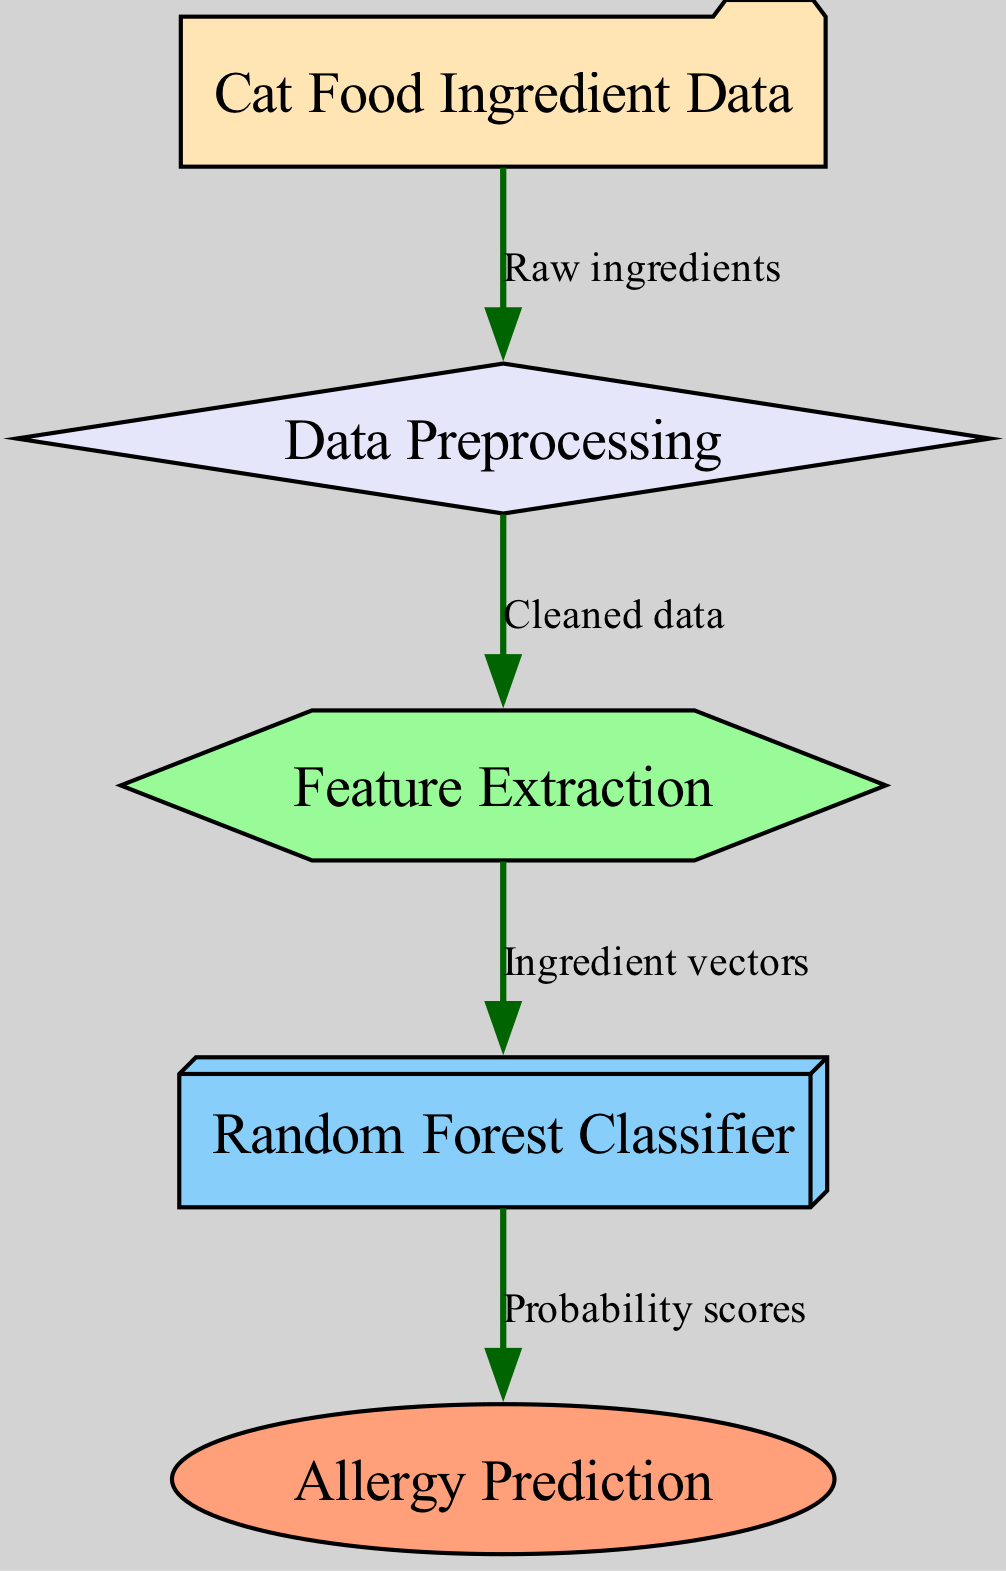What is the first step after receiving cat food ingredient data? The first step after receiving cat food ingredient data is data preprocessing, which cleans the raw ingredients for further analysis.
Answer: Data Preprocessing How many nodes are present in the diagram? There are five nodes in the diagram, representing different stages in the process: input, preprocess, feature, model, and output.
Answer: Five What type of model is used in this diagram? The model used in this diagram is a Random Forest Classifier, which is indicated as the main algorithm for making predictions.
Answer: Random Forest Classifier What is the final output of the model? The final output of the model is allergy prediction, which informs users about the potential allergic reactions based on the cat food ingredient data.
Answer: Allergy Prediction What connects the data preprocessing and feature extraction nodes? The edge connecting data preprocessing and feature extraction nodes indicates the cleaned data that is used for extracting features from the input.
Answer: Cleaned data What is the purpose of the feature extraction step? The purpose of the feature extraction step is to convert cleaned data into ingredient vectors, which are necessary for the machine learning model to operate effectively.
Answer: Ingredient vectors How many edges are there in the diagram? There are four edges in the diagram connecting the various nodes to illustrate the flow of data through the process.
Answer: Four What do the probability scores represent? The probability scores represent the likelihood of allergies based on the predictions made by the Random Forest Classifier, showing how confident the model is about its predictions.
Answer: Probability scores 